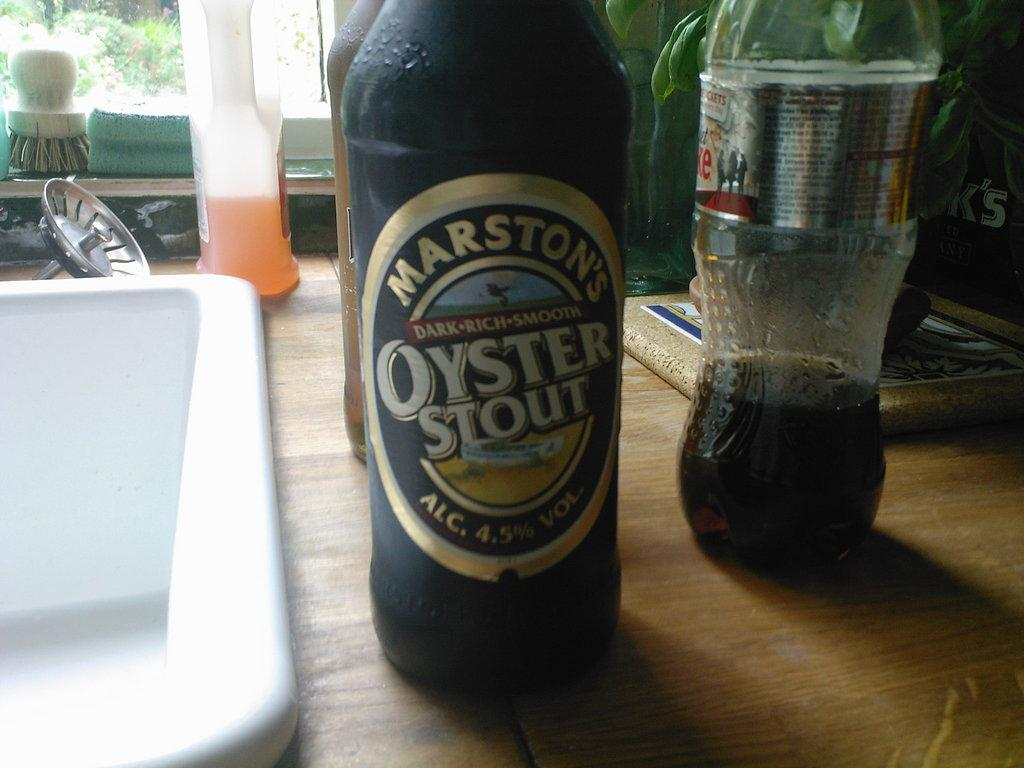How many drink bottles are on the table in the image? There are three drink bottles on the table. What is located beside the drink bottles on the table? There is a white wash basin beside the drink bottles. What type of cap is worn by the person in the image? There is no person present in the image, so it is not possible to determine if anyone is wearing a cap. 